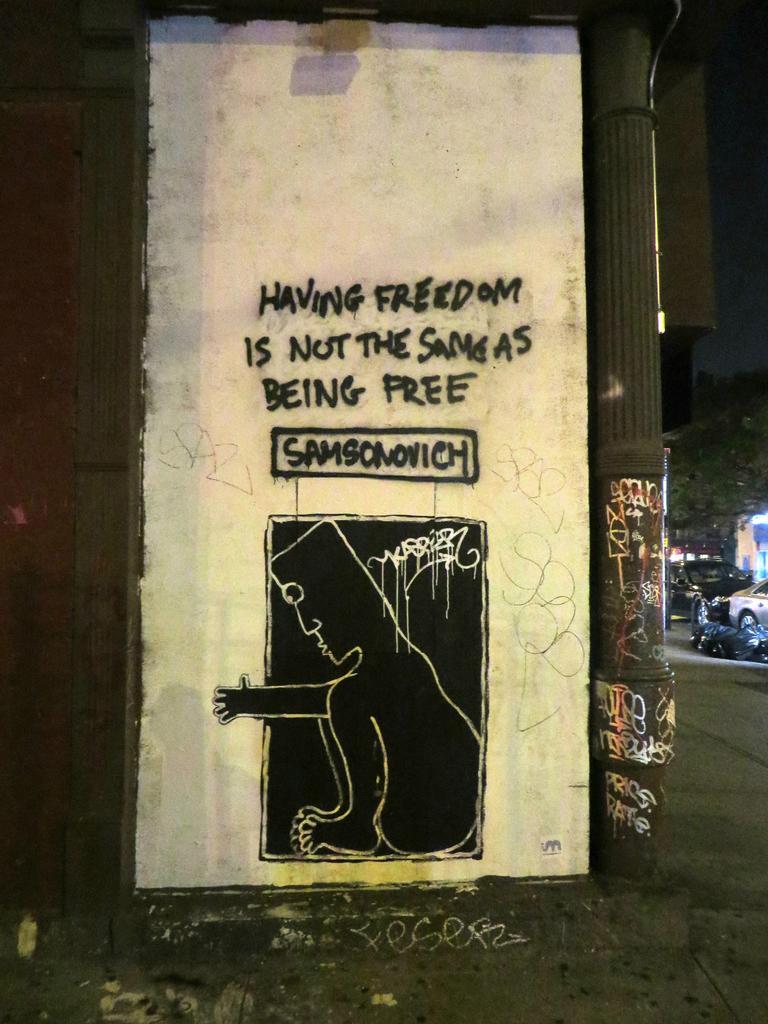Who is the tag artist of this graffiti art?
Offer a terse response. Samsonovich. 